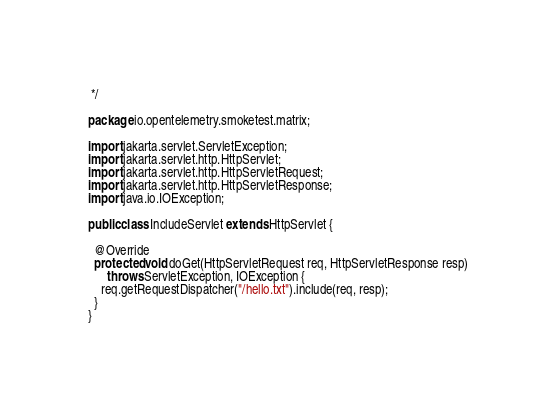<code> <loc_0><loc_0><loc_500><loc_500><_Java_> */

package io.opentelemetry.smoketest.matrix;

import jakarta.servlet.ServletException;
import jakarta.servlet.http.HttpServlet;
import jakarta.servlet.http.HttpServletRequest;
import jakarta.servlet.http.HttpServletResponse;
import java.io.IOException;

public class IncludeServlet extends HttpServlet {

  @Override
  protected void doGet(HttpServletRequest req, HttpServletResponse resp)
      throws ServletException, IOException {
    req.getRequestDispatcher("/hello.txt").include(req, resp);
  }
}
</code> 